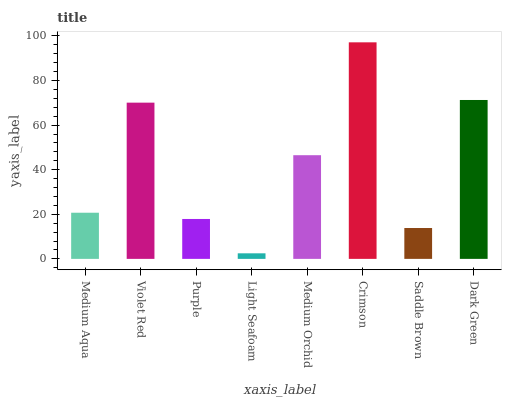Is Light Seafoam the minimum?
Answer yes or no. Yes. Is Crimson the maximum?
Answer yes or no. Yes. Is Violet Red the minimum?
Answer yes or no. No. Is Violet Red the maximum?
Answer yes or no. No. Is Violet Red greater than Medium Aqua?
Answer yes or no. Yes. Is Medium Aqua less than Violet Red?
Answer yes or no. Yes. Is Medium Aqua greater than Violet Red?
Answer yes or no. No. Is Violet Red less than Medium Aqua?
Answer yes or no. No. Is Medium Orchid the high median?
Answer yes or no. Yes. Is Medium Aqua the low median?
Answer yes or no. Yes. Is Medium Aqua the high median?
Answer yes or no. No. Is Purple the low median?
Answer yes or no. No. 